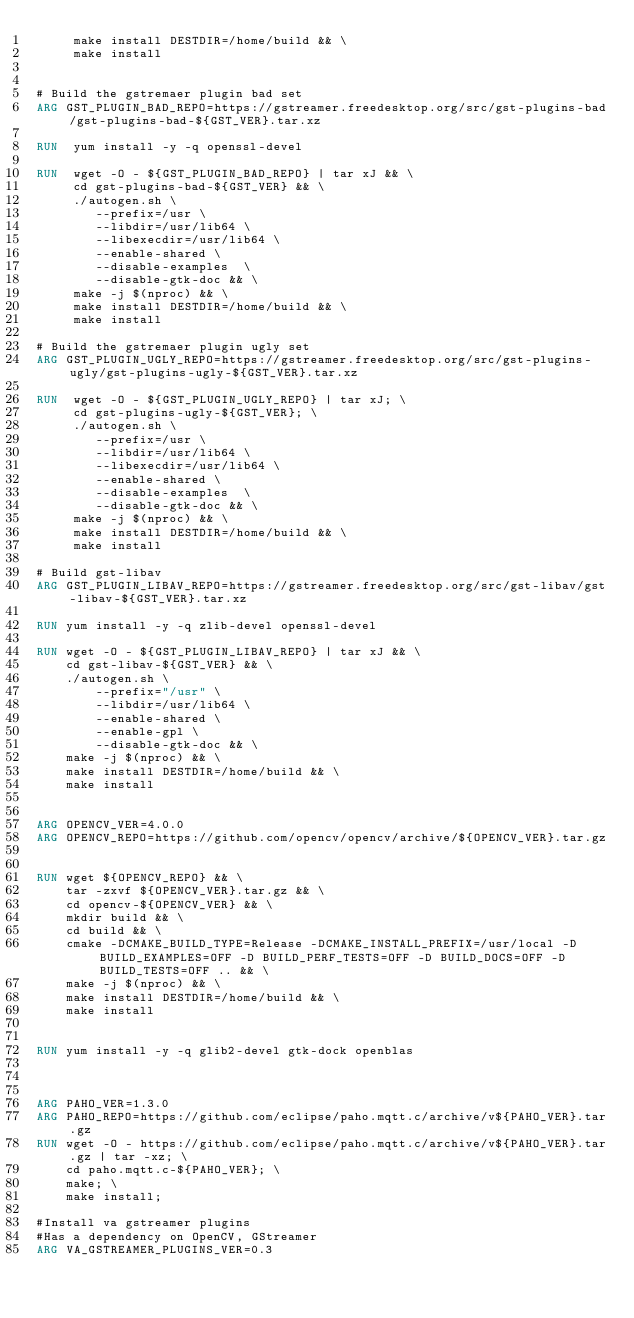Convert code to text. <code><loc_0><loc_0><loc_500><loc_500><_Dockerfile_>     make install DESTDIR=/home/build && \
     make install


# Build the gstremaer plugin bad set
ARG GST_PLUGIN_BAD_REPO=https://gstreamer.freedesktop.org/src/gst-plugins-bad/gst-plugins-bad-${GST_VER}.tar.xz

RUN  yum install -y -q openssl-devel

RUN  wget -O - ${GST_PLUGIN_BAD_REPO} | tar xJ && \
     cd gst-plugins-bad-${GST_VER} && \
     ./autogen.sh \
        --prefix=/usr \
        --libdir=/usr/lib64 \
        --libexecdir=/usr/lib64 \
        --enable-shared \
        --disable-examples  \
        --disable-gtk-doc && \
     make -j $(nproc) && \
     make install DESTDIR=/home/build && \
     make install

# Build the gstremaer plugin ugly set
ARG GST_PLUGIN_UGLY_REPO=https://gstreamer.freedesktop.org/src/gst-plugins-ugly/gst-plugins-ugly-${GST_VER}.tar.xz

RUN  wget -O - ${GST_PLUGIN_UGLY_REPO} | tar xJ; \
     cd gst-plugins-ugly-${GST_VER}; \
     ./autogen.sh \
        --prefix=/usr \
        --libdir=/usr/lib64 \
        --libexecdir=/usr/lib64 \
        --enable-shared \
        --disable-examples  \
        --disable-gtk-doc && \
     make -j $(nproc) && \
     make install DESTDIR=/home/build && \
     make install

# Build gst-libav
ARG GST_PLUGIN_LIBAV_REPO=https://gstreamer.freedesktop.org/src/gst-libav/gst-libav-${GST_VER}.tar.xz

RUN yum install -y -q zlib-devel openssl-devel

RUN wget -O - ${GST_PLUGIN_LIBAV_REPO} | tar xJ && \
    cd gst-libav-${GST_VER} && \
    ./autogen.sh \
        --prefix="/usr" \
        --libdir=/usr/lib64 \
        --enable-shared \
        --enable-gpl \
        --disable-gtk-doc && \
    make -j $(nproc) && \
    make install DESTDIR=/home/build && \
    make install


ARG OPENCV_VER=4.0.0
ARG OPENCV_REPO=https://github.com/opencv/opencv/archive/${OPENCV_VER}.tar.gz


RUN wget ${OPENCV_REPO} && \
    tar -zxvf ${OPENCV_VER}.tar.gz && \
    cd opencv-${OPENCV_VER} && \
    mkdir build && \
    cd build && \
    cmake -DCMAKE_BUILD_TYPE=Release -DCMAKE_INSTALL_PREFIX=/usr/local -D BUILD_EXAMPLES=OFF -D BUILD_PERF_TESTS=OFF -D BUILD_DOCS=OFF -D BUILD_TESTS=OFF .. && \
    make -j $(nproc) && \
    make install DESTDIR=/home/build && \
    make install


RUN yum install -y -q glib2-devel gtk-dock openblas



ARG PAHO_VER=1.3.0
ARG PAHO_REPO=https://github.com/eclipse/paho.mqtt.c/archive/v${PAHO_VER}.tar.gz
RUN wget -O - https://github.com/eclipse/paho.mqtt.c/archive/v${PAHO_VER}.tar.gz | tar -xz; \
    cd paho.mqtt.c-${PAHO_VER}; \
    make; \
    make install;

#Install va gstreamer plugins
#Has a dependency on OpenCV, GStreamer
ARG VA_GSTREAMER_PLUGINS_VER=0.3</code> 